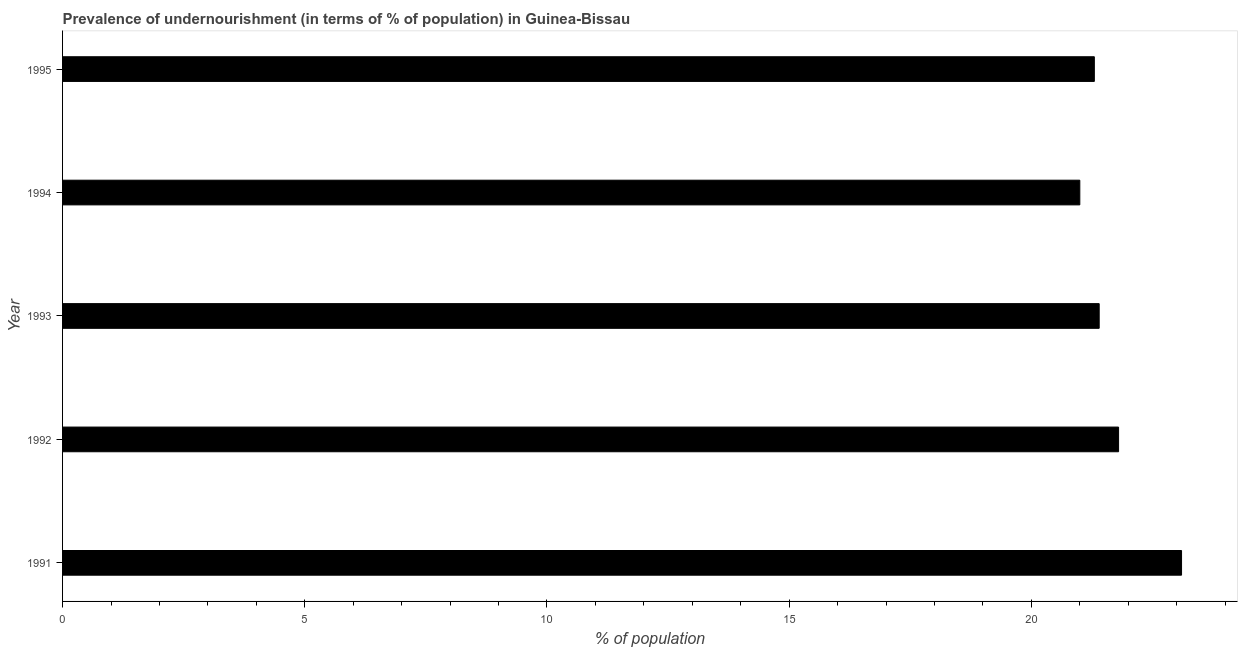Does the graph contain grids?
Keep it short and to the point. No. What is the title of the graph?
Provide a short and direct response. Prevalence of undernourishment (in terms of % of population) in Guinea-Bissau. What is the label or title of the X-axis?
Your answer should be very brief. % of population. What is the percentage of undernourished population in 1995?
Your answer should be compact. 21.3. Across all years, what is the maximum percentage of undernourished population?
Provide a short and direct response. 23.1. In which year was the percentage of undernourished population minimum?
Make the answer very short. 1994. What is the sum of the percentage of undernourished population?
Ensure brevity in your answer.  108.6. What is the average percentage of undernourished population per year?
Provide a succinct answer. 21.72. What is the median percentage of undernourished population?
Make the answer very short. 21.4. In how many years, is the percentage of undernourished population greater than 9 %?
Your answer should be compact. 5. What is the ratio of the percentage of undernourished population in 1991 to that in 1995?
Ensure brevity in your answer.  1.08. Is the percentage of undernourished population in 1991 less than that in 1994?
Provide a succinct answer. No. What is the difference between the highest and the second highest percentage of undernourished population?
Ensure brevity in your answer.  1.3. Is the sum of the percentage of undernourished population in 1993 and 1994 greater than the maximum percentage of undernourished population across all years?
Make the answer very short. Yes. What is the difference between the highest and the lowest percentage of undernourished population?
Your answer should be compact. 2.1. In how many years, is the percentage of undernourished population greater than the average percentage of undernourished population taken over all years?
Keep it short and to the point. 2. How many bars are there?
Ensure brevity in your answer.  5. How many years are there in the graph?
Offer a very short reply. 5. What is the % of population of 1991?
Your response must be concise. 23.1. What is the % of population of 1992?
Your response must be concise. 21.8. What is the % of population of 1993?
Ensure brevity in your answer.  21.4. What is the % of population of 1995?
Your answer should be compact. 21.3. What is the difference between the % of population in 1991 and 1992?
Offer a very short reply. 1.3. What is the difference between the % of population in 1991 and 1993?
Offer a terse response. 1.7. What is the difference between the % of population in 1991 and 1994?
Make the answer very short. 2.1. What is the difference between the % of population in 1992 and 1994?
Your answer should be compact. 0.8. What is the difference between the % of population in 1993 and 1994?
Offer a terse response. 0.4. What is the difference between the % of population in 1993 and 1995?
Keep it short and to the point. 0.1. What is the ratio of the % of population in 1991 to that in 1992?
Your answer should be very brief. 1.06. What is the ratio of the % of population in 1991 to that in 1993?
Make the answer very short. 1.08. What is the ratio of the % of population in 1991 to that in 1995?
Ensure brevity in your answer.  1.08. What is the ratio of the % of population in 1992 to that in 1993?
Your response must be concise. 1.02. What is the ratio of the % of population in 1992 to that in 1994?
Your answer should be compact. 1.04. What is the ratio of the % of population in 1993 to that in 1994?
Offer a terse response. 1.02. What is the ratio of the % of population in 1993 to that in 1995?
Ensure brevity in your answer.  1. 